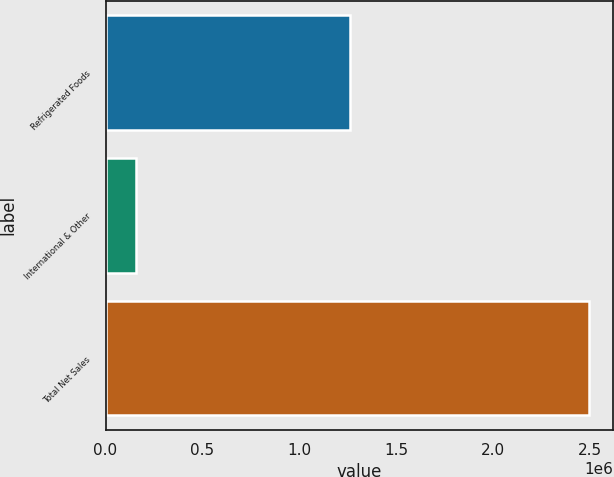Convert chart to OTSL. <chart><loc_0><loc_0><loc_500><loc_500><bar_chart><fcel>Refrigerated Foods<fcel>International & Other<fcel>Total Net Sales<nl><fcel>1.26205e+06<fcel>155130<fcel>2.49261e+06<nl></chart> 